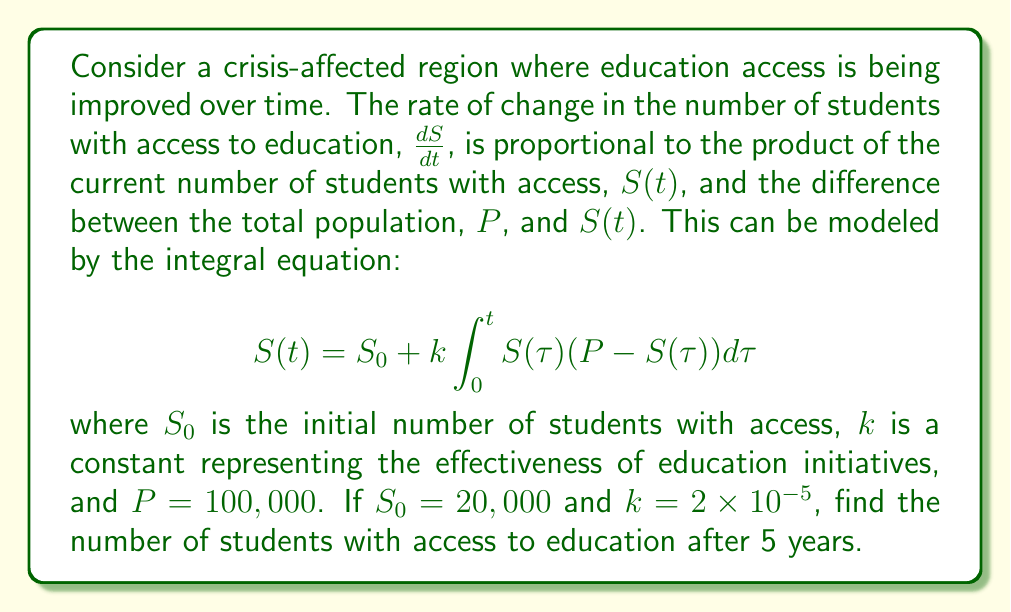Can you solve this math problem? To solve this integral equation, we'll follow these steps:

1) First, we recognize this as a logistic growth model. The solution to this type of equation is known to be:

   $$S(t) = \frac{P}{1 + (\frac{P}{S_0} - 1)e^{-kPt}}$$

2) We're given the following values:
   $P = 100,000$
   $S_0 = 20,000$
   $k = 2 \times 10^{-5}$
   $t = 5$ (years)

3) Let's substitute these values into our solution:

   $$S(5) = \frac{100,000}{1 + (\frac{100,000}{20,000} - 1)e^{-(2 \times 10^{-5})(100,000)(5)}}$$

4) Simplify the fraction inside the parentheses:

   $$S(5) = \frac{100,000}{1 + (5 - 1)e^{-10}}$$

5) Calculate the exponent:
   $e^{-10} \approx 4.54 \times 10^{-5}$

6) Substitute this value:

   $$S(5) = \frac{100,000}{1 + (4)(4.54 \times 10^{-5})}$$

7) Simplify:

   $$S(5) = \frac{100,000}{1.000182} \approx 99,981.82$$

8) Since we're dealing with number of students, we round down to the nearest whole number.
Answer: 99,981 students 